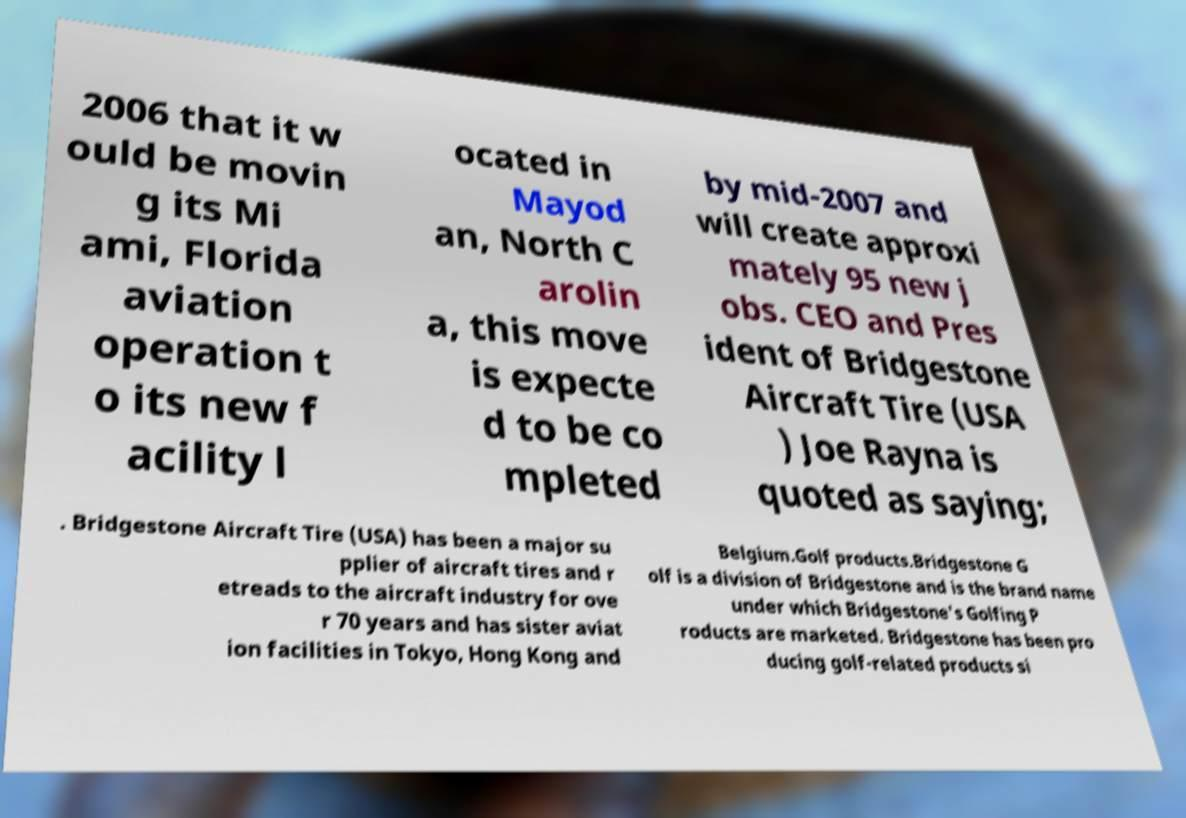There's text embedded in this image that I need extracted. Can you transcribe it verbatim? 2006 that it w ould be movin g its Mi ami, Florida aviation operation t o its new f acility l ocated in Mayod an, North C arolin a, this move is expecte d to be co mpleted by mid-2007 and will create approxi mately 95 new j obs. CEO and Pres ident of Bridgestone Aircraft Tire (USA ) Joe Rayna is quoted as saying; . Bridgestone Aircraft Tire (USA) has been a major su pplier of aircraft tires and r etreads to the aircraft industry for ove r 70 years and has sister aviat ion facilities in Tokyo, Hong Kong and Belgium.Golf products.Bridgestone G olf is a division of Bridgestone and is the brand name under which Bridgestone's Golfing P roducts are marketed. Bridgestone has been pro ducing golf-related products si 